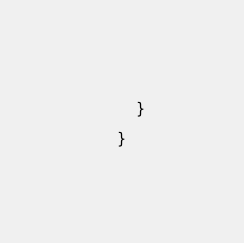Convert code to text. <code><loc_0><loc_0><loc_500><loc_500><_Java_>	    }

	}

</code> 